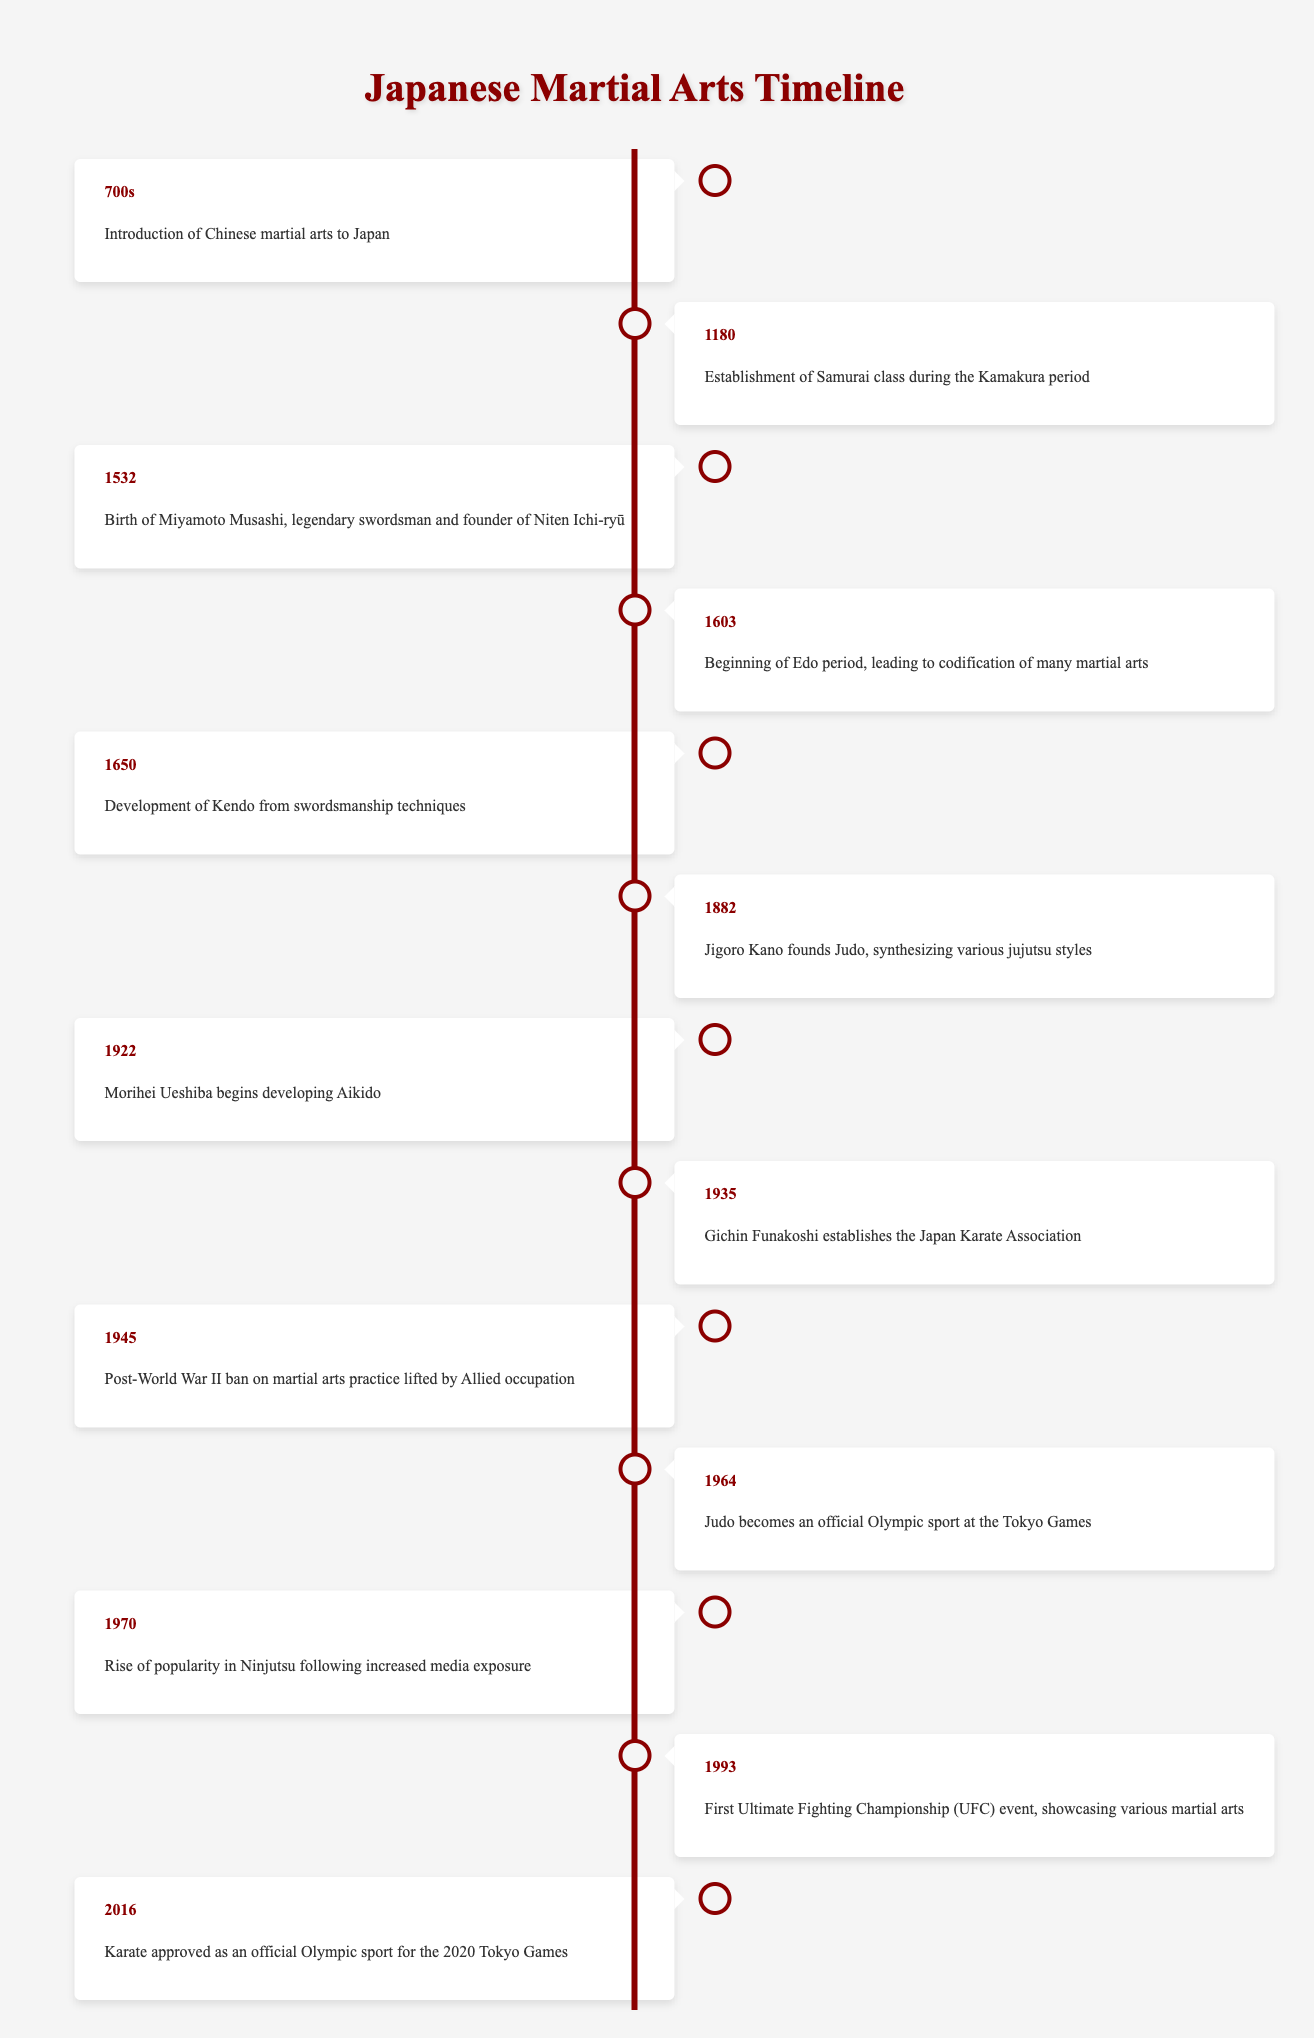What year was Judo founded? Judo was founded by Jigoro Kano in 1882, as stated in the timeline.
Answer: 1882 What event marks the beginning of the Edo period? The starting point of the Edo period is 1603, when it led to the codification of many martial arts.
Answer: 1603 How many years passed between the establishment of the Samurai class and the founding of Judo? The Samurai class was established in 1180, and Judo was founded in 1882. The difference is 1882 - 1180 = 702 years.
Answer: 702 years Was Karate approved as an official Olympic sport before 2016? According to the timeline, Karate was approved as an official Olympic sport in 2016, which indicates it was not approved before that year.
Answer: No Which martial art was developed from swordsmanship techniques? The timeline specifies that Kendo was developed from swordsmanship techniques in the year 1650.
Answer: Kendo What is the chronological order of the following events: the birth of Miyamoto Musashi, the establishment of the Samurai class, and the founding of Judo? The events occur in the following order: establishment of Samurai class (1180), birth of Miyamoto Musashi (1532), and founding of Judo (1882). This is determined by looking at their respective years on the timeline.
Answer: Samurai class → Musashi's birth → Judo founding What significant event occurred in 1945 regarding martial arts? The timeline indicates that in 1945, the post-World War II ban on martial arts practice was lifted by the Allied occupation.
Answer: Ban lifted In what year did the first Ultimate Fighting Championship (UFC) event take place? The timeline shows that the first UFC event occurred in 1993.
Answer: 1993 How many key events are listed in the timeline of Japanese martial arts? Counting the events in the timeline, there are a total of 14 key milestones mentioned.
Answer: 14 events 